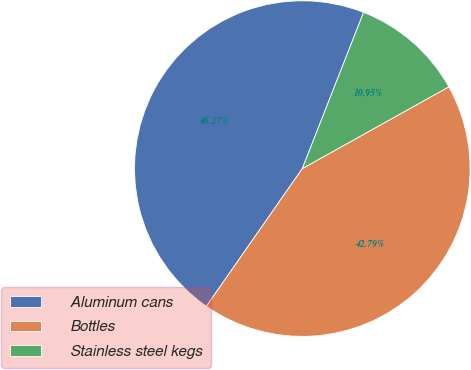<chart> <loc_0><loc_0><loc_500><loc_500><pie_chart><fcel>Aluminum cans<fcel>Bottles<fcel>Stainless steel kegs<nl><fcel>46.27%<fcel>42.79%<fcel>10.95%<nl></chart> 